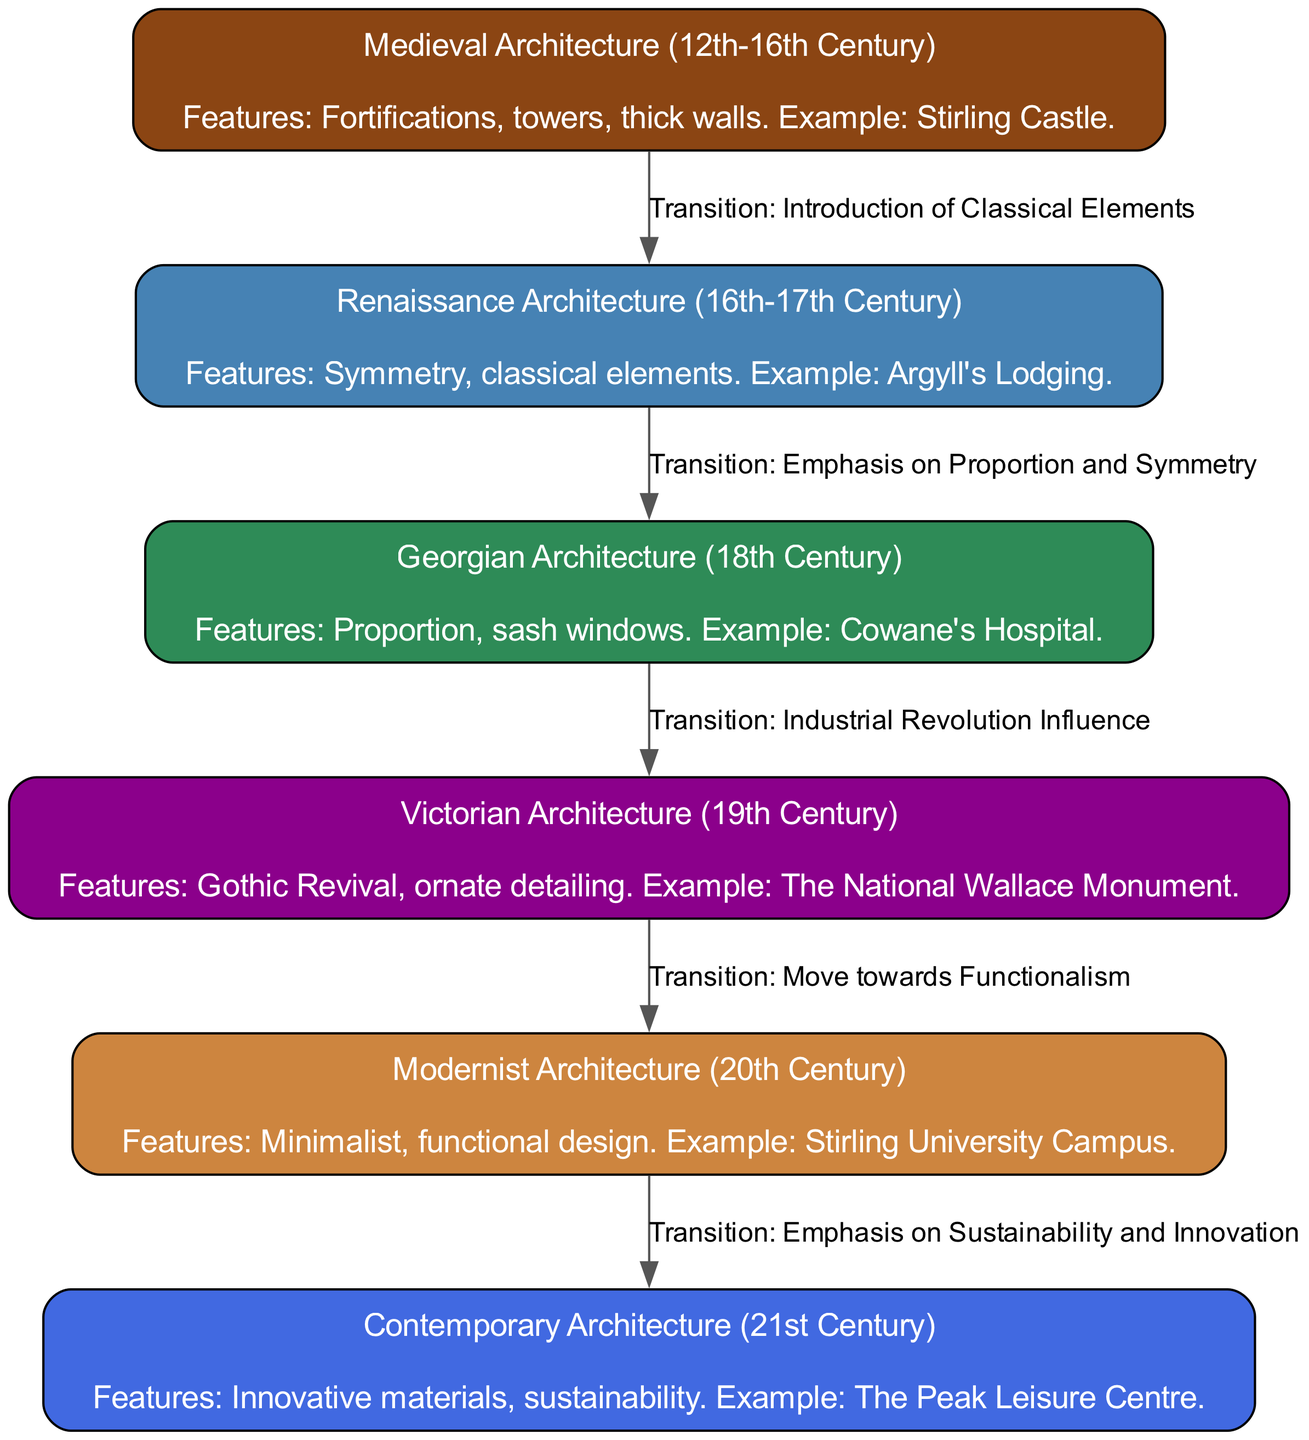What architectural style is represented by Stirling Castle? The diagram indicates that Stirling Castle is an example of Medieval Architecture, which is identified in the node labeled "Medieval Architecture (12th-16th Century)".
Answer: Medieval Architecture What features characterize Georgian architecture? The diagram outlines that Georgian Architecture includes features such as proportion and sash windows, noted in the node labeled "Georgian Architecture (18th Century)".
Answer: Proportion, sash windows What is the transition that occurs from Victorian buildings to 20th century modernism? The diagram shows that the transition between these two architectural styles is labeled as "Move towards Functionalism". This transition is depicted in the edge connecting the nodes "Victorian Architecture (19th Century)" and "Modernist Architecture (20th Century)".
Answer: Move towards Functionalism How many architectural styles are presented in the diagram? By counting the nodes in the diagram, we find there are six architectural styles represented: Medieval, Renaissance, Georgian, Victorian, Modernist, and Contemporary.
Answer: Six Which architectural style followed Renaissance architecture? The diagram indicates that Georgian Architecture follows Renaissance Architecture, as evidenced by the directed edge from "Renaissance Architecture (16th-17th Century)" to "Georgian Architecture (18th Century)".
Answer: Georgian Architecture What is a key feature of contemporary architecture? The diagram describes that contemporary architecture features innovative materials and sustainability, as noted in the node labeled "Contemporary Architecture (21st Century)".
Answer: Innovative materials, sustainability Which building is an example of Victorian architecture? The diagram specifically cites "The National Wallace Monument" as an example of Victorian Architecture, found in the node labeled "Victorian Architecture (19th Century)".
Answer: The National Wallace Monument What style is characterized by symmetrical design? The diagram notes that symmetry is a central feature of Renaissance architecture, represented in the node labeled "Renaissance Architecture (16th-17th Century)".
Answer: Renaissance Architecture What transitional influence led to Victorian Architecture? The diagram highlights that the influence of the Industrial Revolution is the transition that led to Victorian architecture, which links the nodes for Georgian houses and Victorian buildings.
Answer: Industrial Revolution Influence 